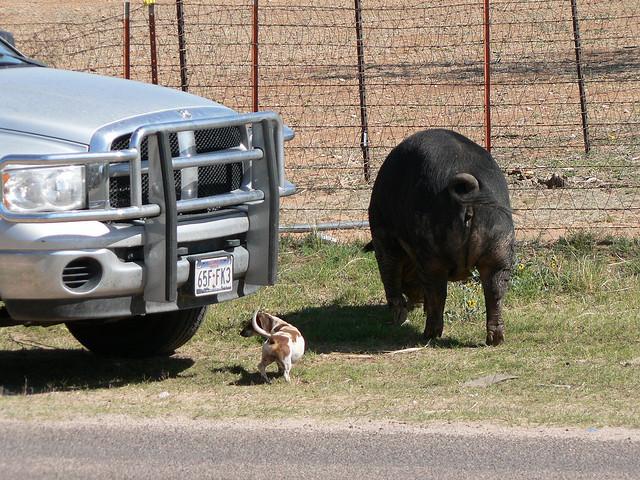What kind of animals?
Keep it brief. Pig and dog. How many animals are in the picture?
Quick response, please. 2. What are the silver bars on the front of the truck used for?
Quick response, please. Protection. How many animals?
Keep it brief. 2. 